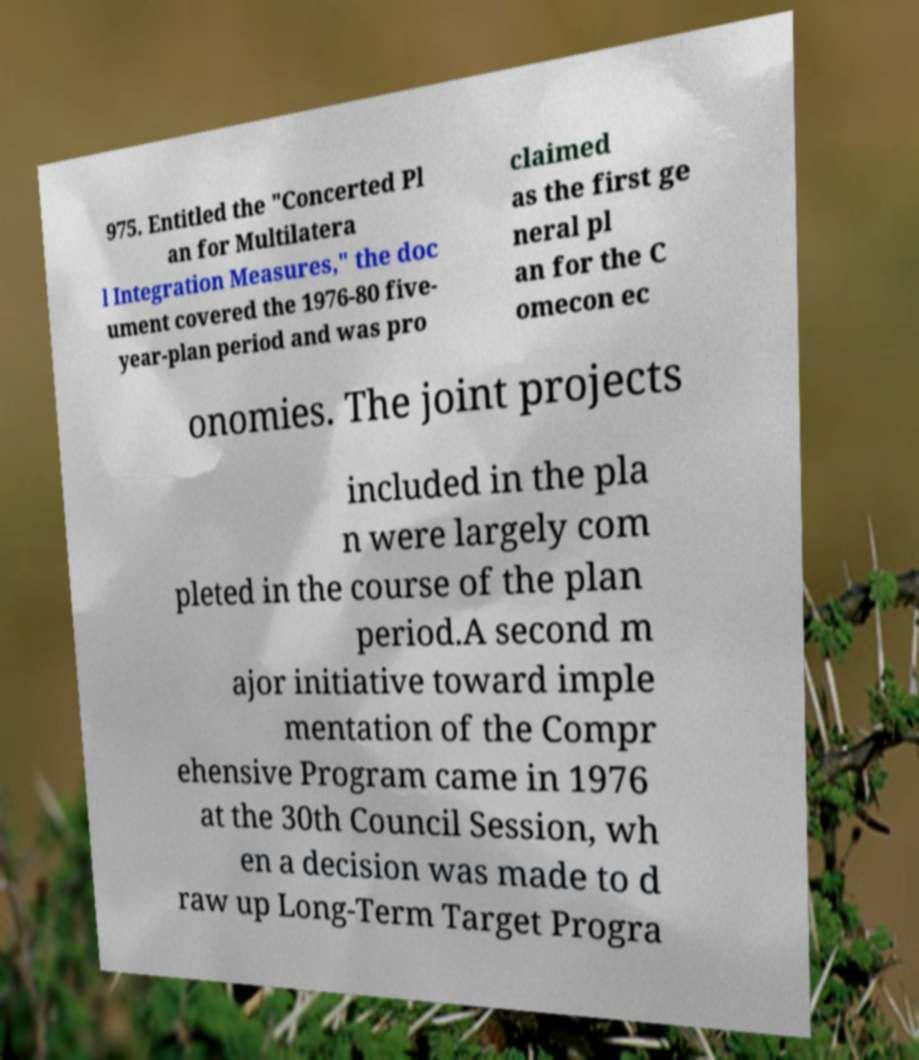Could you assist in decoding the text presented in this image and type it out clearly? 975. Entitled the "Concerted Pl an for Multilatera l Integration Measures," the doc ument covered the 1976-80 five- year-plan period and was pro claimed as the first ge neral pl an for the C omecon ec onomies. The joint projects included in the pla n were largely com pleted in the course of the plan period.A second m ajor initiative toward imple mentation of the Compr ehensive Program came in 1976 at the 30th Council Session, wh en a decision was made to d raw up Long-Term Target Progra 